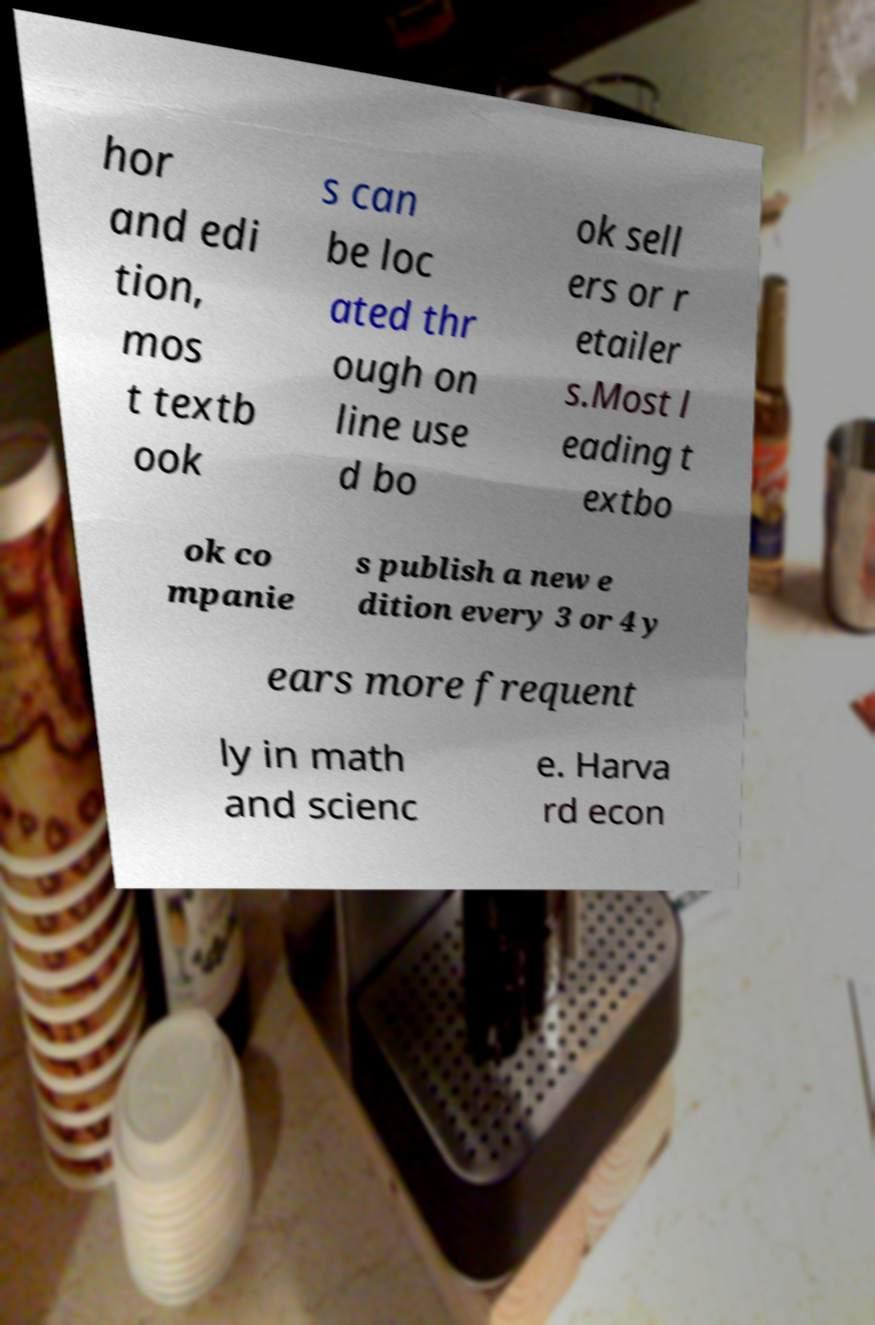For documentation purposes, I need the text within this image transcribed. Could you provide that? hor and edi tion, mos t textb ook s can be loc ated thr ough on line use d bo ok sell ers or r etailer s.Most l eading t extbo ok co mpanie s publish a new e dition every 3 or 4 y ears more frequent ly in math and scienc e. Harva rd econ 